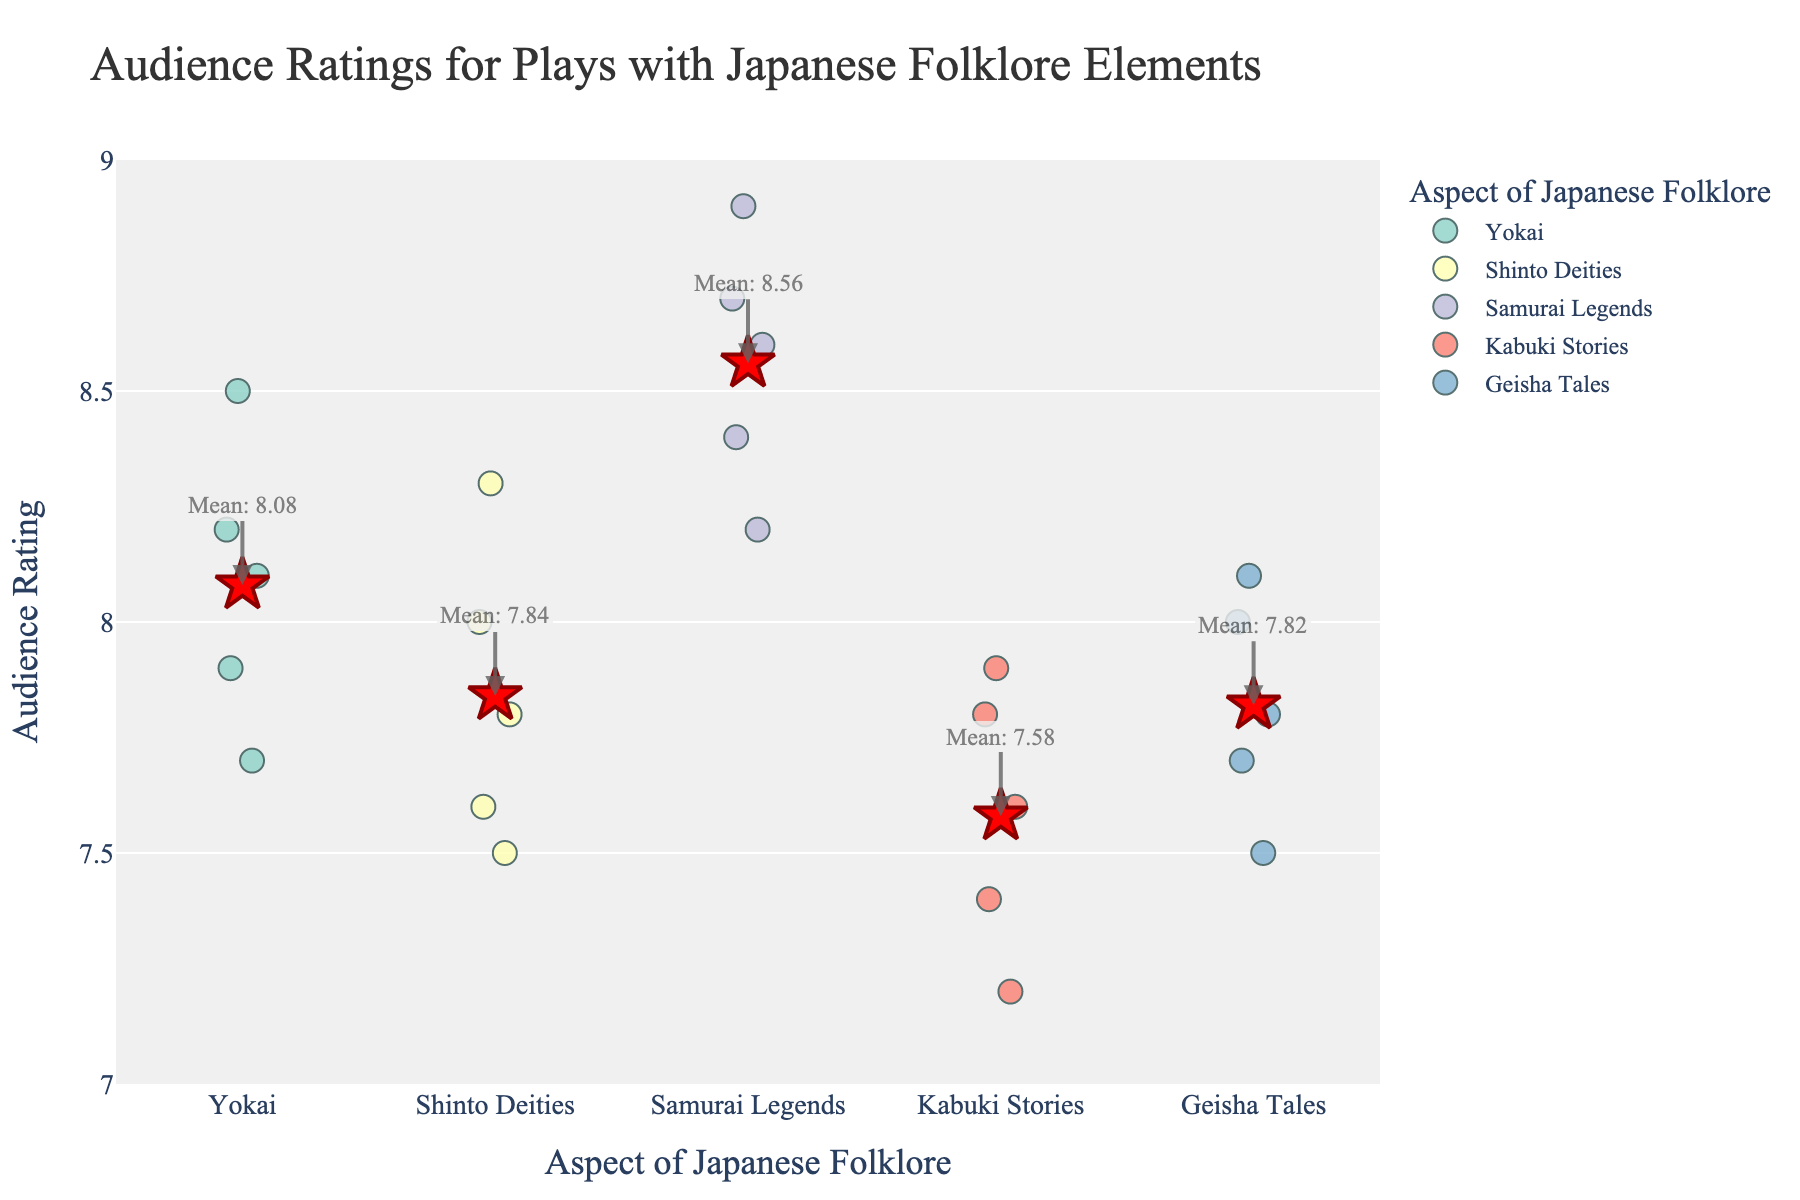What's the title of the strip plot? The title is at the top of the plot and provides a general description of the visualized data.
Answer: "Audience Ratings for Plays with Japanese Folklore Elements" What is the average rating for Kabuki Stories? The average rating is marked by a star symbol and an annotation on the plot for Kabuki Stories.
Answer: 7.58 Which aspect has the highest mean rating? The mean ratings are annotated on the plot. The aspect with the highest value next to its annotation is the one with the highest mean rating.
Answer: Samurai Legends How many data points are there for Yokai? Data points are represented by circles on the plot. Count the number of circles above Yokai on the x-axis.
Answer: 5 What is the range of audience ratings for Samurai Legends? The range is the difference between the highest and lowest data points above Samurai Legends on the y-axis.
Answer: 8.9 - 8.2 Which aspect shows the greatest variation in ratings? The aspect with the most spread-out data points on the y-axis indicates the greatest variation.
Answer: Kabuki Stories How does the average rating of Geisha Tales compare to Shinto Deities? Compare the mean rating annotations for Geisha Tales and Shinto Deities.
Answer: Geisha Tales has a lower average rating than Shinto Deities What is the median rating for Shinto Deities? The median rating is the middle value when the ratings are sorted. For Shinto Deities: 7.5, 7.6, 7.8, 8.0, 8.3. The middle value is 7.8.
Answer: 7.8 